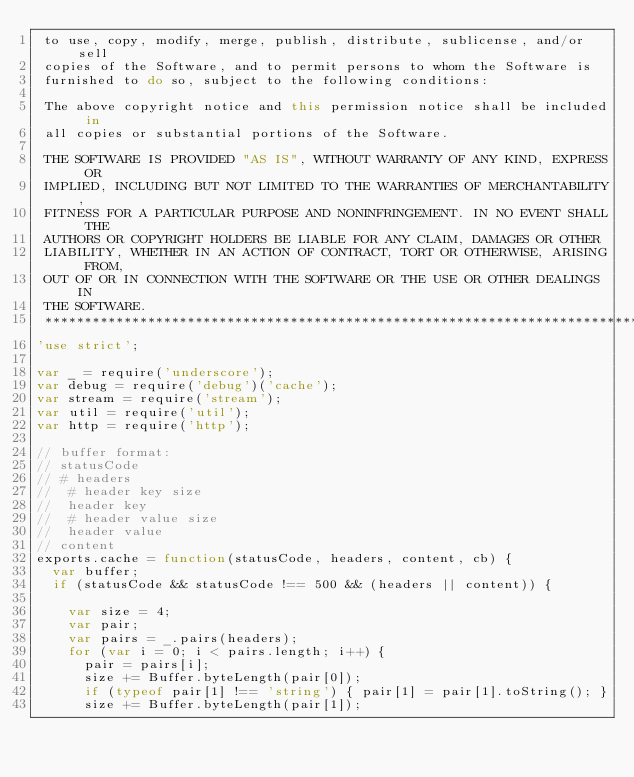<code> <loc_0><loc_0><loc_500><loc_500><_JavaScript_> to use, copy, modify, merge, publish, distribute, sublicense, and/or sell
 copies of the Software, and to permit persons to whom the Software is
 furnished to do so, subject to the following conditions:

 The above copyright notice and this permission notice shall be included in
 all copies or substantial portions of the Software.

 THE SOFTWARE IS PROVIDED "AS IS", WITHOUT WARRANTY OF ANY KIND, EXPRESS OR
 IMPLIED, INCLUDING BUT NOT LIMITED TO THE WARRANTIES OF MERCHANTABILITY,
 FITNESS FOR A PARTICULAR PURPOSE AND NONINFRINGEMENT. IN NO EVENT SHALL THE
 AUTHORS OR COPYRIGHT HOLDERS BE LIABLE FOR ANY CLAIM, DAMAGES OR OTHER
 LIABILITY, WHETHER IN AN ACTION OF CONTRACT, TORT OR OTHERWISE, ARISING FROM,
 OUT OF OR IN CONNECTION WITH THE SOFTWARE OR THE USE OR OTHER DEALINGS IN
 THE SOFTWARE.
 ****************************************************************************/
'use strict';

var _ = require('underscore');
var debug = require('debug')('cache');
var stream = require('stream');
var util = require('util');
var http = require('http');

// buffer format:
// statusCode
// # headers
//  # header key size
//  header key
//  # header value size
//  header value
// content
exports.cache = function(statusCode, headers, content, cb) {
  var buffer;
  if (statusCode && statusCode !== 500 && (headers || content)) {

    var size = 4;
    var pair;
    var pairs = _.pairs(headers);
    for (var i = 0; i < pairs.length; i++) {
      pair = pairs[i];
      size += Buffer.byteLength(pair[0]);
      if (typeof pair[1] !== 'string') { pair[1] = pair[1].toString(); }
      size += Buffer.byteLength(pair[1]);</code> 